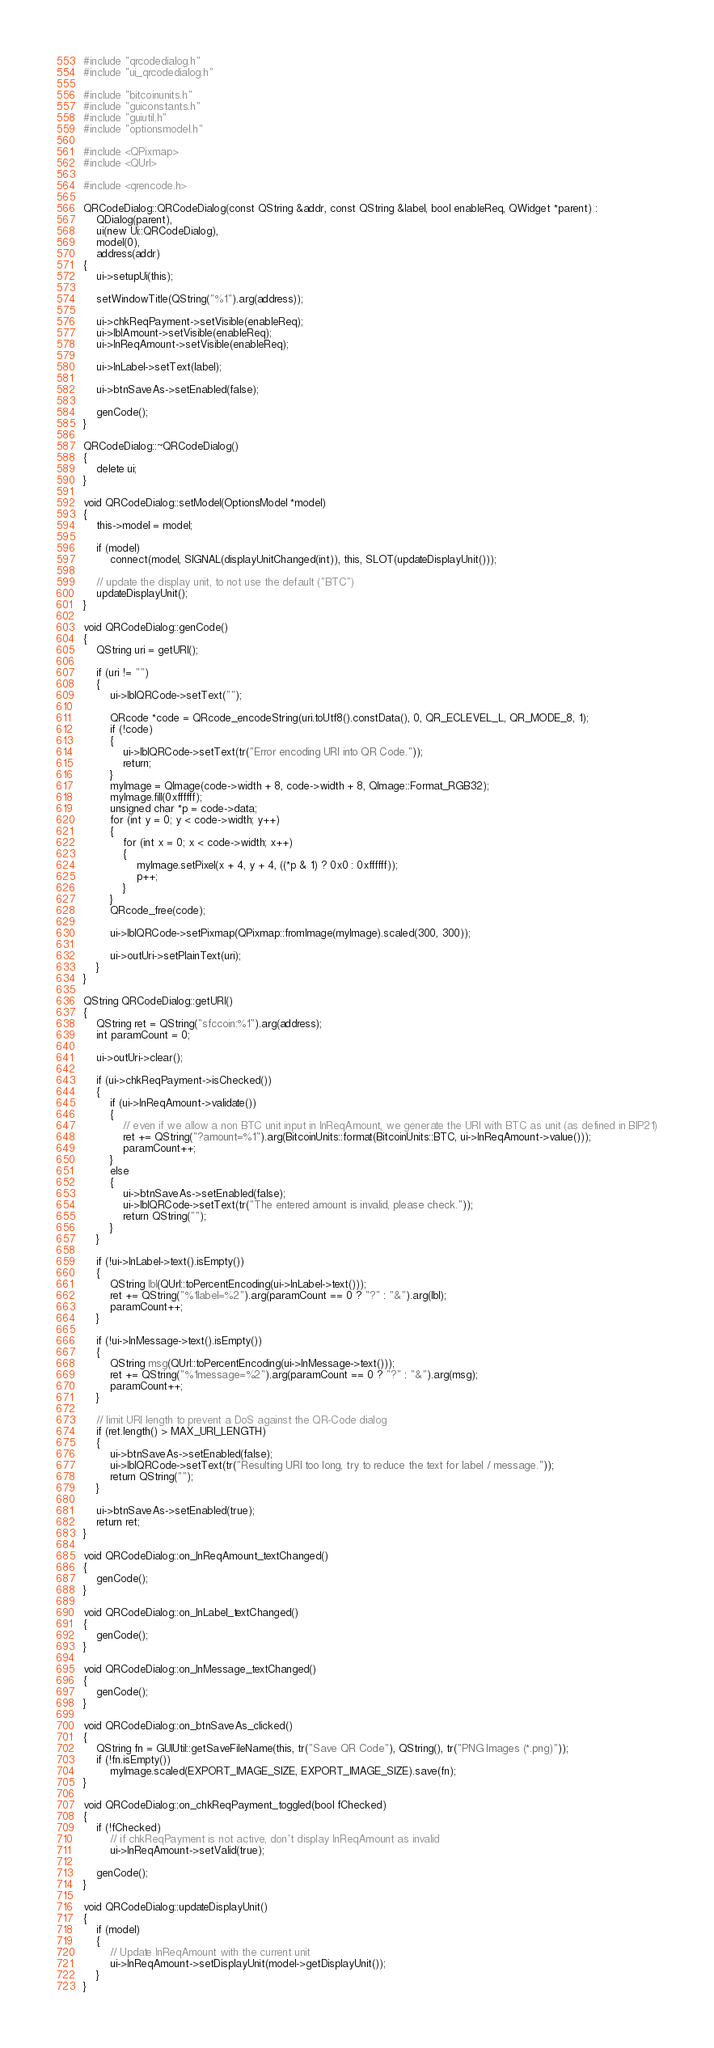Convert code to text. <code><loc_0><loc_0><loc_500><loc_500><_C++_>#include "qrcodedialog.h"
#include "ui_qrcodedialog.h"

#include "bitcoinunits.h"
#include "guiconstants.h"
#include "guiutil.h"
#include "optionsmodel.h"

#include <QPixmap>
#include <QUrl>

#include <qrencode.h>

QRCodeDialog::QRCodeDialog(const QString &addr, const QString &label, bool enableReq, QWidget *parent) :
    QDialog(parent),
    ui(new Ui::QRCodeDialog),
    model(0),
    address(addr)
{
    ui->setupUi(this);

    setWindowTitle(QString("%1").arg(address));

    ui->chkReqPayment->setVisible(enableReq);
    ui->lblAmount->setVisible(enableReq);
    ui->lnReqAmount->setVisible(enableReq);

    ui->lnLabel->setText(label);

    ui->btnSaveAs->setEnabled(false);

    genCode();
}

QRCodeDialog::~QRCodeDialog()
{
    delete ui;
}

void QRCodeDialog::setModel(OptionsModel *model)
{
    this->model = model;

    if (model)
        connect(model, SIGNAL(displayUnitChanged(int)), this, SLOT(updateDisplayUnit()));

    // update the display unit, to not use the default ("BTC")
    updateDisplayUnit();
}

void QRCodeDialog::genCode()
{
    QString uri = getURI();

    if (uri != "")
    {
        ui->lblQRCode->setText("");

        QRcode *code = QRcode_encodeString(uri.toUtf8().constData(), 0, QR_ECLEVEL_L, QR_MODE_8, 1);
        if (!code)
        {
            ui->lblQRCode->setText(tr("Error encoding URI into QR Code."));
            return;
        }
        myImage = QImage(code->width + 8, code->width + 8, QImage::Format_RGB32);
        myImage.fill(0xffffff);
        unsigned char *p = code->data;
        for (int y = 0; y < code->width; y++)
        {
            for (int x = 0; x < code->width; x++)
            {
                myImage.setPixel(x + 4, y + 4, ((*p & 1) ? 0x0 : 0xffffff));
                p++;
            }
        }
        QRcode_free(code);

        ui->lblQRCode->setPixmap(QPixmap::fromImage(myImage).scaled(300, 300));

        ui->outUri->setPlainText(uri);
    }
}

QString QRCodeDialog::getURI()
{
    QString ret = QString("sfccoin:%1").arg(address);
    int paramCount = 0;

    ui->outUri->clear();

    if (ui->chkReqPayment->isChecked())
    {
        if (ui->lnReqAmount->validate())
        {
            // even if we allow a non BTC unit input in lnReqAmount, we generate the URI with BTC as unit (as defined in BIP21)
            ret += QString("?amount=%1").arg(BitcoinUnits::format(BitcoinUnits::BTC, ui->lnReqAmount->value()));
            paramCount++;
        }
        else
        {
            ui->btnSaveAs->setEnabled(false);
            ui->lblQRCode->setText(tr("The entered amount is invalid, please check."));
            return QString("");
        }
    }

    if (!ui->lnLabel->text().isEmpty())
    {
        QString lbl(QUrl::toPercentEncoding(ui->lnLabel->text()));
        ret += QString("%1label=%2").arg(paramCount == 0 ? "?" : "&").arg(lbl);
        paramCount++;
    }

    if (!ui->lnMessage->text().isEmpty())
    {
        QString msg(QUrl::toPercentEncoding(ui->lnMessage->text()));
        ret += QString("%1message=%2").arg(paramCount == 0 ? "?" : "&").arg(msg);
        paramCount++;
    }

    // limit URI length to prevent a DoS against the QR-Code dialog
    if (ret.length() > MAX_URI_LENGTH)
    {
        ui->btnSaveAs->setEnabled(false);
        ui->lblQRCode->setText(tr("Resulting URI too long, try to reduce the text for label / message."));
        return QString("");
    }

    ui->btnSaveAs->setEnabled(true);
    return ret;
}

void QRCodeDialog::on_lnReqAmount_textChanged()
{
    genCode();
}

void QRCodeDialog::on_lnLabel_textChanged()
{
    genCode();
}

void QRCodeDialog::on_lnMessage_textChanged()
{
    genCode();
}

void QRCodeDialog::on_btnSaveAs_clicked()
{
    QString fn = GUIUtil::getSaveFileName(this, tr("Save QR Code"), QString(), tr("PNG Images (*.png)"));
    if (!fn.isEmpty())
        myImage.scaled(EXPORT_IMAGE_SIZE, EXPORT_IMAGE_SIZE).save(fn);
}

void QRCodeDialog::on_chkReqPayment_toggled(bool fChecked)
{
    if (!fChecked)
        // if chkReqPayment is not active, don't display lnReqAmount as invalid
        ui->lnReqAmount->setValid(true);

    genCode();
}

void QRCodeDialog::updateDisplayUnit()
{
    if (model)
    {
        // Update lnReqAmount with the current unit
        ui->lnReqAmount->setDisplayUnit(model->getDisplayUnit());
    }
}
</code> 